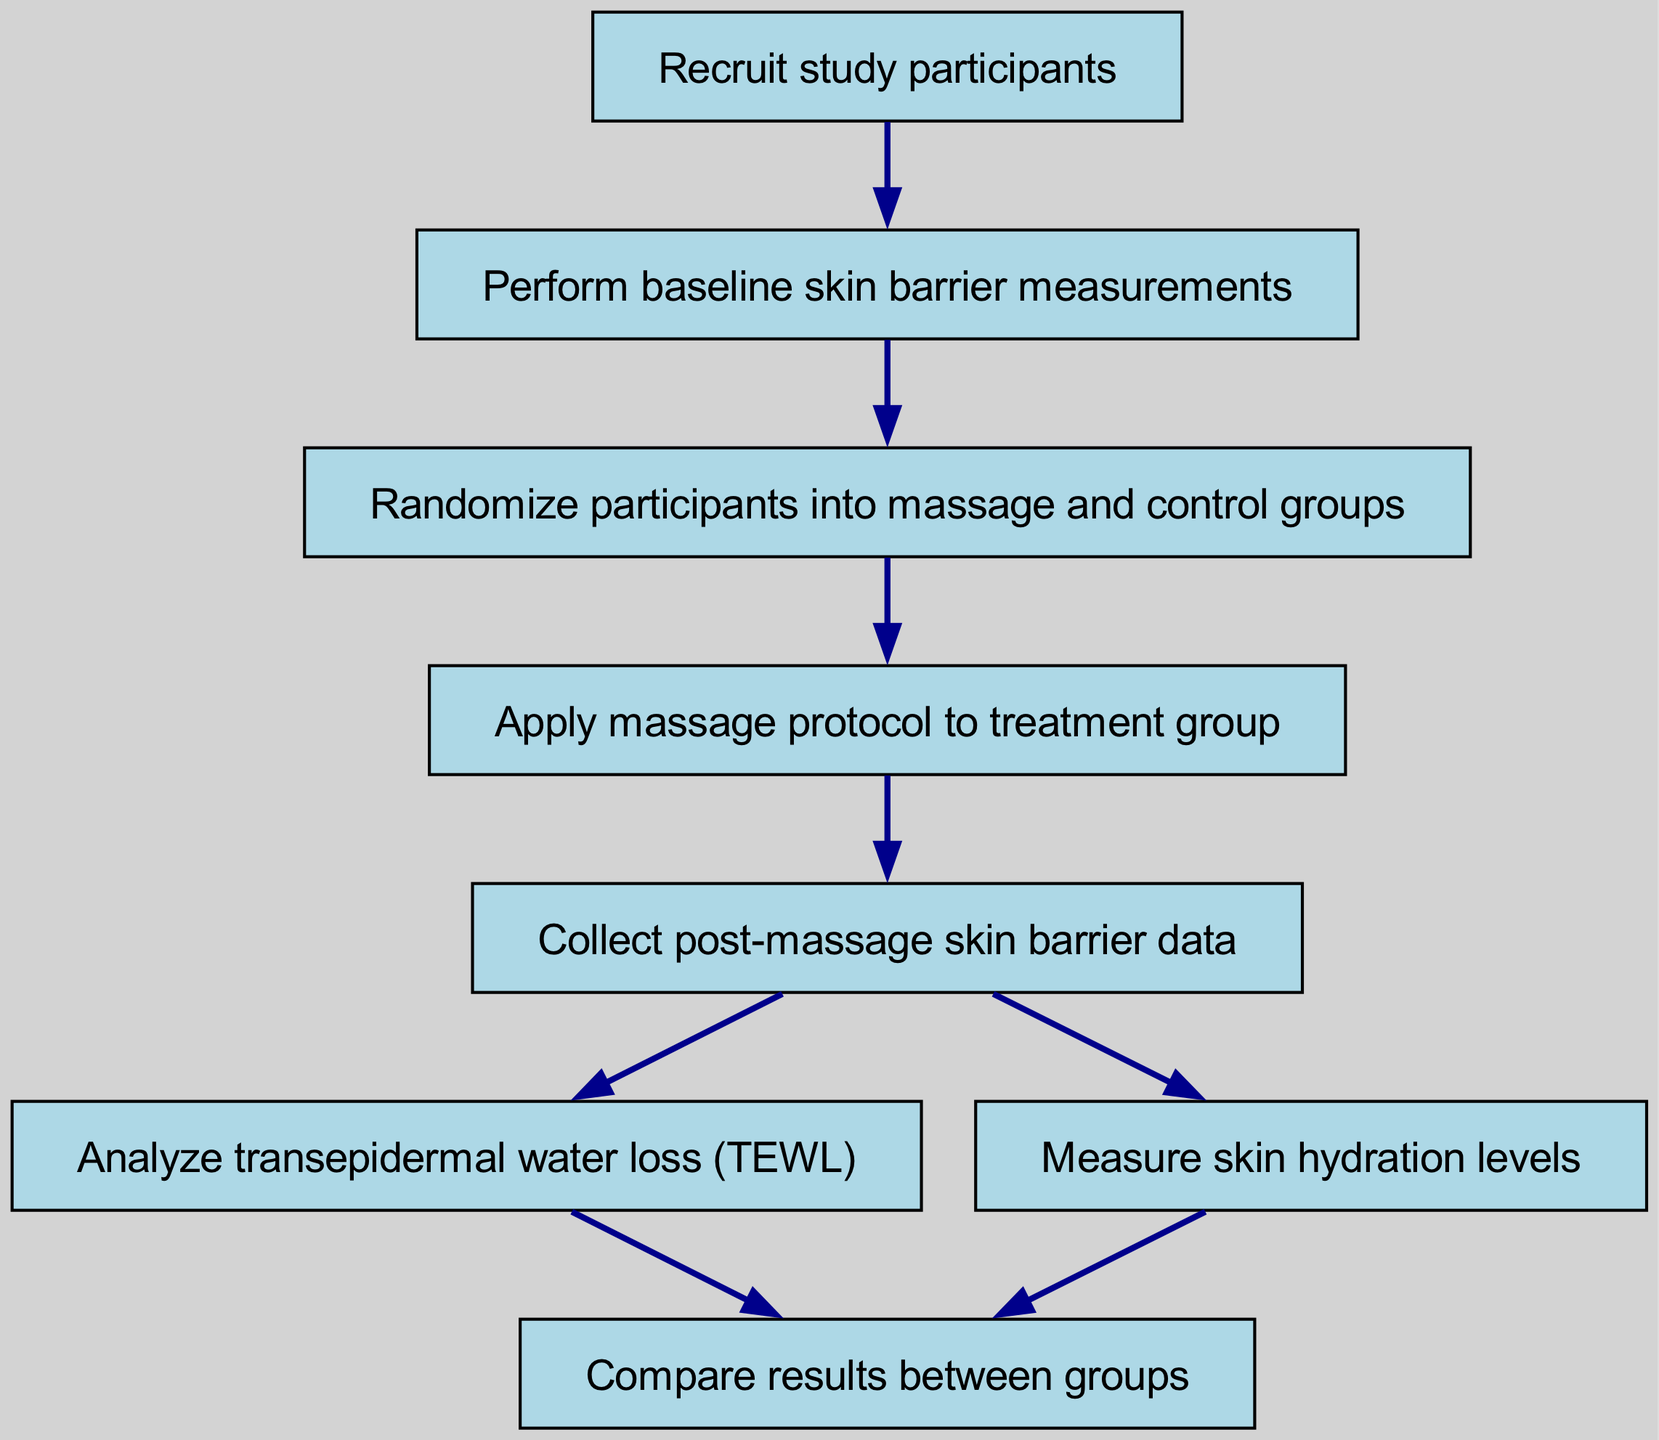What is the first step in the data collection process? The first step in the data collection process, as indicated in the diagram, is to "Recruit study participants." This is the starting point before any measurements are taken.
Answer: Recruit study participants How many nodes are in the diagram? The diagram contains a total of eight distinct nodes, each representing a step in the data collection process.
Answer: Eight What happens after performing baseline skin barrier measurements? After baseline measurements, participants are randomized into massage and control groups. This step follows directly from the baseline measurements.
Answer: Randomize participants into massage and control groups What is the last step in the data collection process? The final step in the data collection process is to "Compare results between groups", which concludes the analysis phase of the study.
Answer: Compare results between groups Which two nodes follow the "Collect post-massage skin barrier data" node? The nodes following "Collect post-massage skin barrier data" are "Analyze transepidermal water loss (TEWL)" and "Measure skin hydration levels." Both steps are essential for assessing the impact of the treatment.
Answer: Analyze transepidermal water loss (TEWL) and Measure skin hydration levels What is the relationship between the node "Apply massage protocol to treatment group" and the node "Collect post-massage skin barrier data"? The node "Apply massage protocol to treatment group" leads directly to the subsequent step "Collect post-massage skin barrier data", indicating that the data collection occurs after the massage protocol has been applied.
Answer: Apply massage protocol to treatment group → Collect post-massage skin barrier data Which two measurements are analyzed after data collection? After collecting the data, the two measurements analyzed are transepidermal water loss (TEWL) and skin hydration levels. Both analyses are crucial for evaluating skin barrier function.
Answer: Transepidermal water loss (TEWL) and skin hydration levels What is the purpose of randomizing participants into groups? Randomizing participants into groups ensures that the study results are unbiased and that any observed effects can be attributed to the massage protocol, rather than differences in participant characteristics.
Answer: Unbiased results How many edges are in the diagram? The diagram features a total of seven edges that connect the nodes, illustrating the flow of the data collection process.
Answer: Seven 